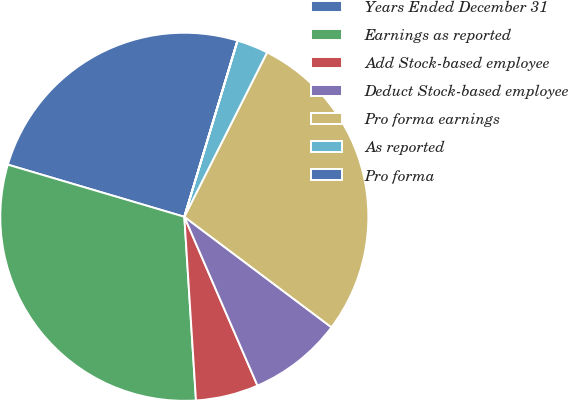<chart> <loc_0><loc_0><loc_500><loc_500><pie_chart><fcel>Years Ended December 31<fcel>Earnings as reported<fcel>Add Stock-based employee<fcel>Deduct Stock-based employee<fcel>Pro forma earnings<fcel>As reported<fcel>Pro forma<nl><fcel>25.09%<fcel>30.58%<fcel>5.5%<fcel>8.24%<fcel>27.83%<fcel>2.75%<fcel>0.01%<nl></chart> 